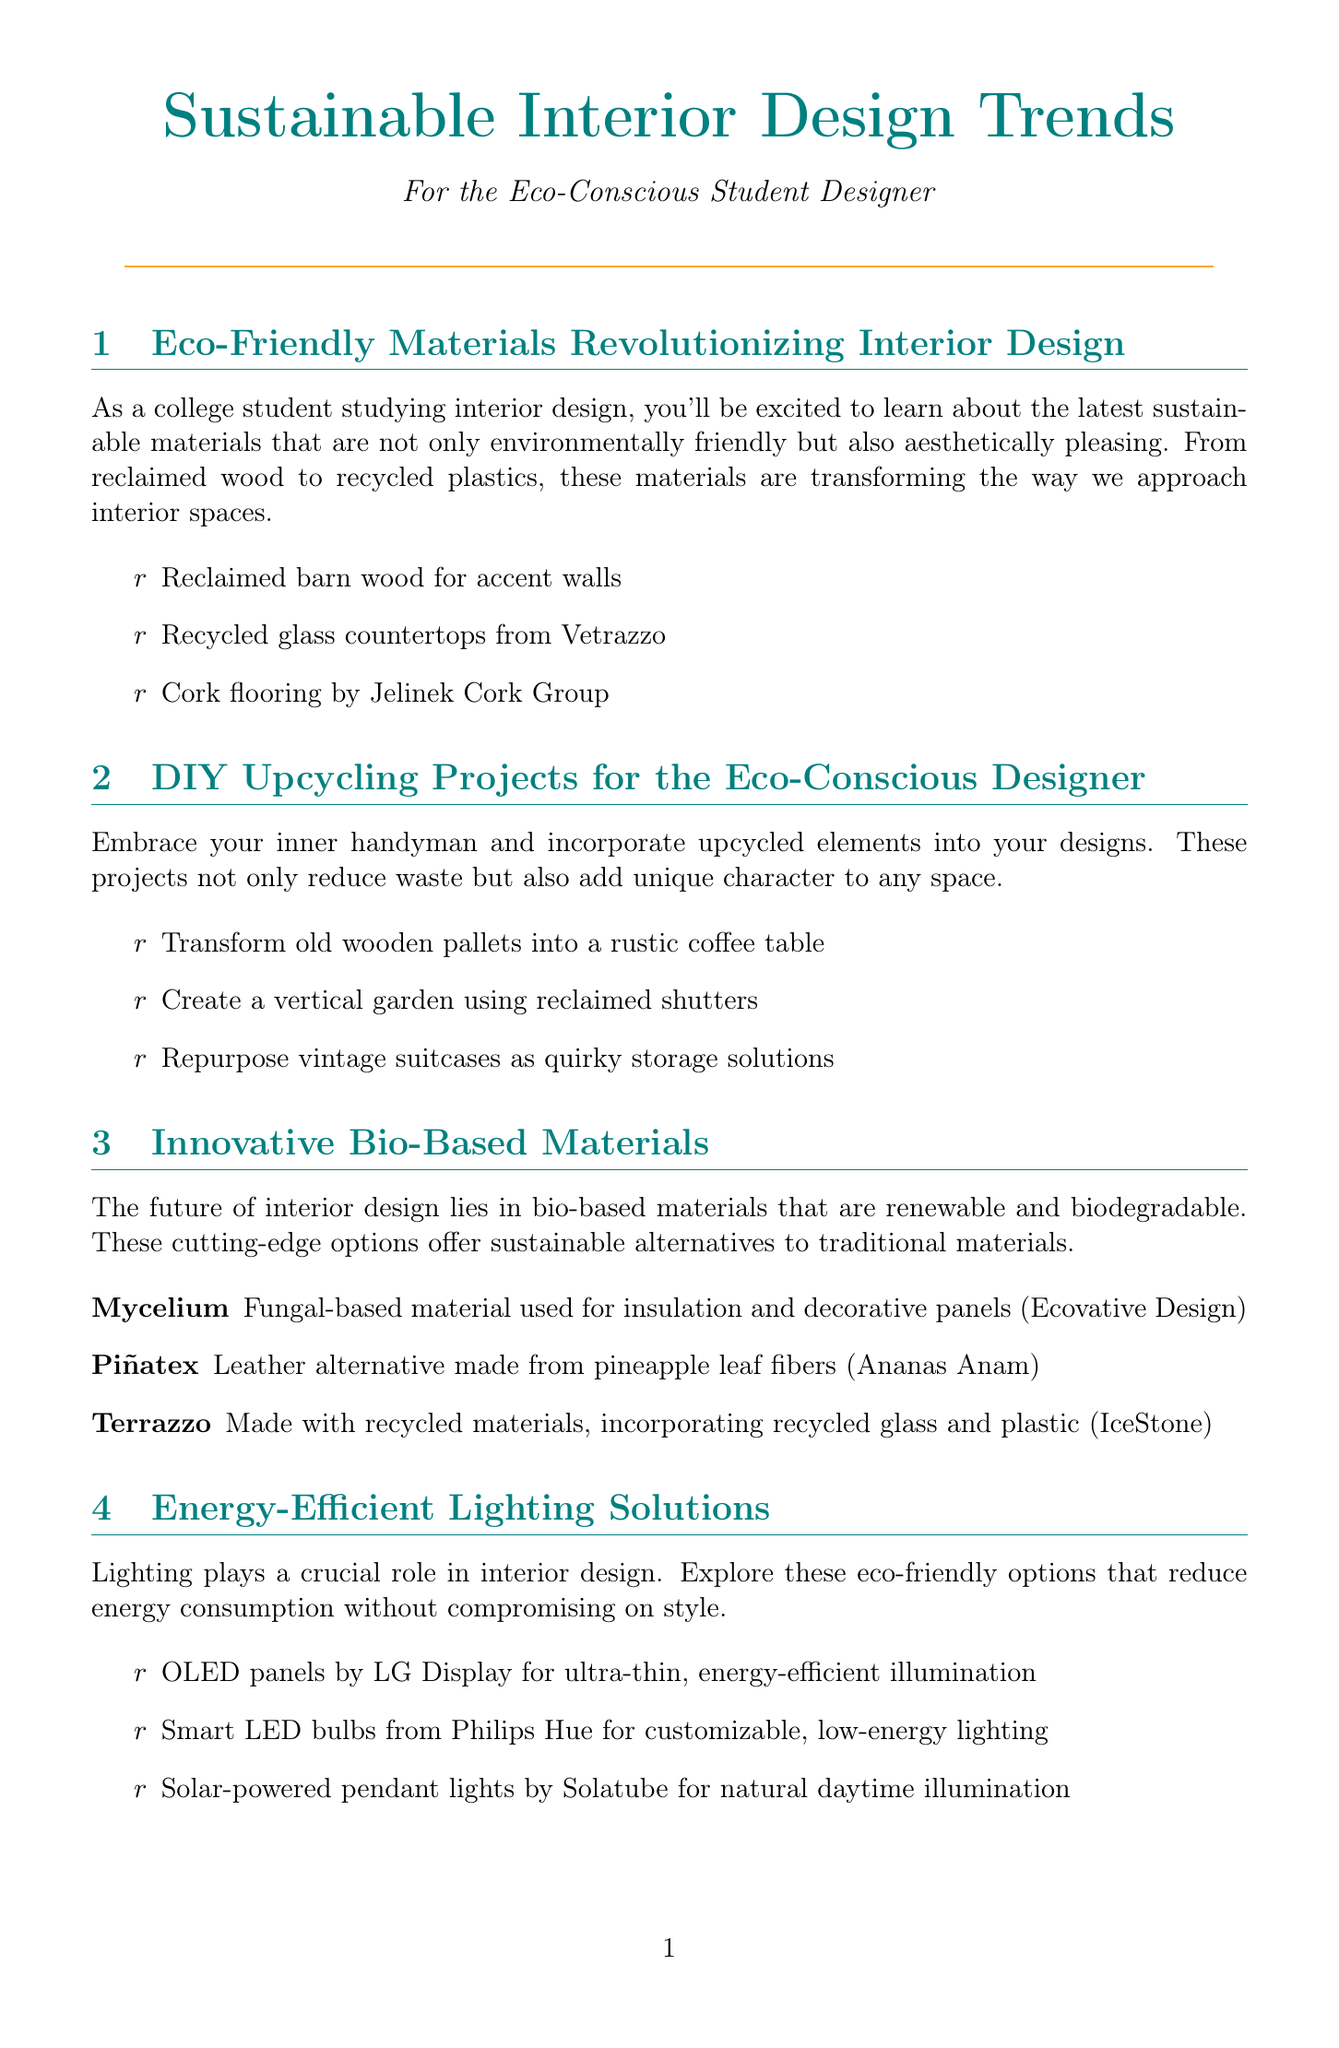What is one example of a sustainable material mentioned? The document lists various eco-friendly materials, including reclaimed barn wood for accent walls.
Answer: Reclaimed barn wood What is a suggested DIY project using old wooden pallets? The newsletter provides ideas for upcycling, including transforming old wooden pallets into a rustic coffee table.
Answer: Rustic coffee table What is Mycelium used for? Mycelium is identified as a fungal-based material used for insulation and decorative panels.
Answer: Insulation and decorative panels Which lighting option is solar-powered? The document mentions various eco-friendly lighting options, including solar-powered pendant lights by Solatube.
Answer: Solar-powered pendant lights What certification ensures responsibly sourced wood products? The letter mentions certifications; FSC is listed as one that ensures responsibly sourced wood products.
Answer: FSC What is Piñatex made from? According to the text, Piñatex is a leather alternative made from pineapple leaf fibers.
Answer: Pineapple leaf fibers How many categories of eco-certifications are listed? The document provides a list of certifications, specifically mentioning three different ones.
Answer: Three What type of flooring incorporates recycled materials? The newsletter points out that Terrazzo made with recycled materials is a flooring option.
Answer: Terrazzo Name one sustainable textile example provided. The document contains examples of sustainable textiles, including organic cotton upholstery fabric by Kravet Eco.
Answer: Organic cotton upholstery fabric 